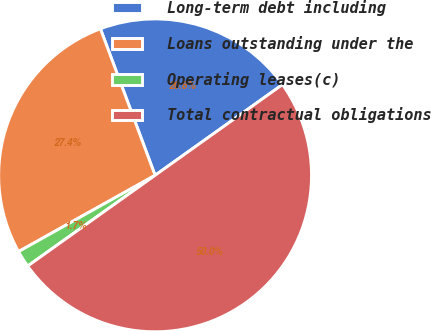<chart> <loc_0><loc_0><loc_500><loc_500><pie_chart><fcel>Long-term debt including<fcel>Loans outstanding under the<fcel>Operating leases(c)<fcel>Total contractual obligations<nl><fcel>20.83%<fcel>27.42%<fcel>1.74%<fcel>50.0%<nl></chart> 